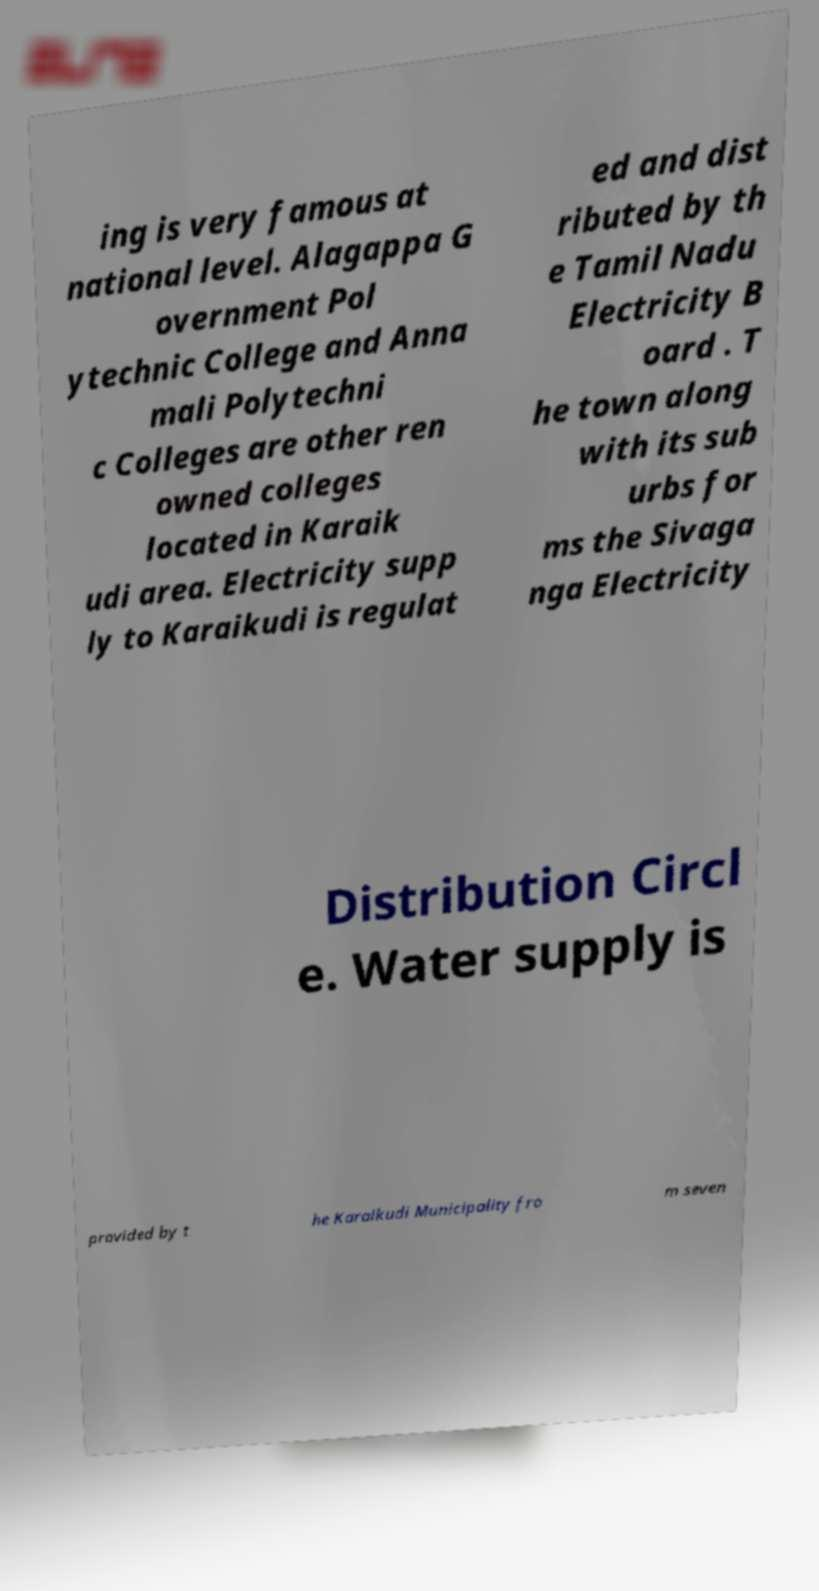I need the written content from this picture converted into text. Can you do that? ing is very famous at national level. Alagappa G overnment Pol ytechnic College and Anna mali Polytechni c Colleges are other ren owned colleges located in Karaik udi area. Electricity supp ly to Karaikudi is regulat ed and dist ributed by th e Tamil Nadu Electricity B oard . T he town along with its sub urbs for ms the Sivaga nga Electricity Distribution Circl e. Water supply is provided by t he Karaikudi Municipality fro m seven 